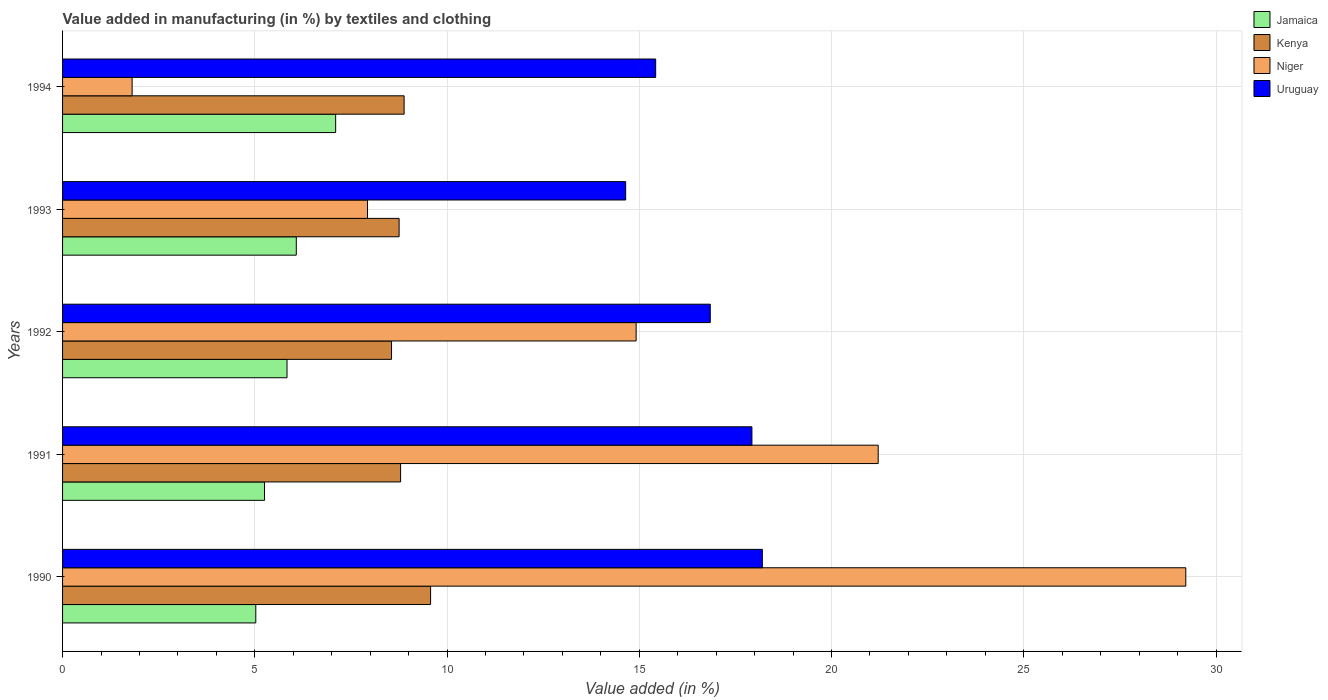How many groups of bars are there?
Give a very brief answer. 5. Are the number of bars on each tick of the Y-axis equal?
Your response must be concise. Yes. In how many cases, is the number of bars for a given year not equal to the number of legend labels?
Offer a terse response. 0. What is the percentage of value added in manufacturing by textiles and clothing in Kenya in 1990?
Provide a short and direct response. 9.57. Across all years, what is the maximum percentage of value added in manufacturing by textiles and clothing in Kenya?
Give a very brief answer. 9.57. Across all years, what is the minimum percentage of value added in manufacturing by textiles and clothing in Jamaica?
Ensure brevity in your answer.  5.03. What is the total percentage of value added in manufacturing by textiles and clothing in Jamaica in the graph?
Your answer should be compact. 29.3. What is the difference between the percentage of value added in manufacturing by textiles and clothing in Jamaica in 1990 and that in 1991?
Your answer should be very brief. -0.23. What is the difference between the percentage of value added in manufacturing by textiles and clothing in Uruguay in 1992 and the percentage of value added in manufacturing by textiles and clothing in Niger in 1991?
Offer a very short reply. -4.37. What is the average percentage of value added in manufacturing by textiles and clothing in Niger per year?
Offer a very short reply. 15.02. In the year 1994, what is the difference between the percentage of value added in manufacturing by textiles and clothing in Uruguay and percentage of value added in manufacturing by textiles and clothing in Jamaica?
Ensure brevity in your answer.  8.32. In how many years, is the percentage of value added in manufacturing by textiles and clothing in Jamaica greater than 1 %?
Provide a short and direct response. 5. What is the ratio of the percentage of value added in manufacturing by textiles and clothing in Niger in 1991 to that in 1994?
Keep it short and to the point. 11.73. Is the difference between the percentage of value added in manufacturing by textiles and clothing in Uruguay in 1990 and 1993 greater than the difference between the percentage of value added in manufacturing by textiles and clothing in Jamaica in 1990 and 1993?
Offer a terse response. Yes. What is the difference between the highest and the second highest percentage of value added in manufacturing by textiles and clothing in Jamaica?
Ensure brevity in your answer.  1.02. What is the difference between the highest and the lowest percentage of value added in manufacturing by textiles and clothing in Niger?
Provide a short and direct response. 27.4. In how many years, is the percentage of value added in manufacturing by textiles and clothing in Uruguay greater than the average percentage of value added in manufacturing by textiles and clothing in Uruguay taken over all years?
Give a very brief answer. 3. What does the 1st bar from the top in 1990 represents?
Offer a very short reply. Uruguay. What does the 3rd bar from the bottom in 1992 represents?
Keep it short and to the point. Niger. Is it the case that in every year, the sum of the percentage of value added in manufacturing by textiles and clothing in Uruguay and percentage of value added in manufacturing by textiles and clothing in Jamaica is greater than the percentage of value added in manufacturing by textiles and clothing in Niger?
Provide a succinct answer. No. How many bars are there?
Your answer should be compact. 20. How many years are there in the graph?
Your response must be concise. 5. What is the difference between two consecutive major ticks on the X-axis?
Offer a terse response. 5. Where does the legend appear in the graph?
Your answer should be compact. Top right. How are the legend labels stacked?
Keep it short and to the point. Vertical. What is the title of the graph?
Make the answer very short. Value added in manufacturing (in %) by textiles and clothing. What is the label or title of the X-axis?
Your answer should be very brief. Value added (in %). What is the Value added (in %) in Jamaica in 1990?
Provide a short and direct response. 5.03. What is the Value added (in %) of Kenya in 1990?
Provide a succinct answer. 9.57. What is the Value added (in %) in Niger in 1990?
Keep it short and to the point. 29.21. What is the Value added (in %) of Uruguay in 1990?
Your answer should be very brief. 18.2. What is the Value added (in %) in Jamaica in 1991?
Make the answer very short. 5.25. What is the Value added (in %) in Kenya in 1991?
Offer a very short reply. 8.79. What is the Value added (in %) of Niger in 1991?
Offer a very short reply. 21.21. What is the Value added (in %) of Uruguay in 1991?
Ensure brevity in your answer.  17.93. What is the Value added (in %) in Jamaica in 1992?
Ensure brevity in your answer.  5.84. What is the Value added (in %) of Kenya in 1992?
Offer a very short reply. 8.56. What is the Value added (in %) of Niger in 1992?
Your answer should be compact. 14.92. What is the Value added (in %) of Uruguay in 1992?
Keep it short and to the point. 16.85. What is the Value added (in %) in Jamaica in 1993?
Make the answer very short. 6.08. What is the Value added (in %) of Kenya in 1993?
Provide a short and direct response. 8.75. What is the Value added (in %) of Niger in 1993?
Your answer should be compact. 7.93. What is the Value added (in %) in Uruguay in 1993?
Your answer should be very brief. 14.65. What is the Value added (in %) of Jamaica in 1994?
Provide a short and direct response. 7.1. What is the Value added (in %) of Kenya in 1994?
Provide a short and direct response. 8.88. What is the Value added (in %) of Niger in 1994?
Keep it short and to the point. 1.81. What is the Value added (in %) in Uruguay in 1994?
Your answer should be compact. 15.43. Across all years, what is the maximum Value added (in %) of Jamaica?
Keep it short and to the point. 7.1. Across all years, what is the maximum Value added (in %) in Kenya?
Keep it short and to the point. 9.57. Across all years, what is the maximum Value added (in %) of Niger?
Keep it short and to the point. 29.21. Across all years, what is the maximum Value added (in %) in Uruguay?
Provide a short and direct response. 18.2. Across all years, what is the minimum Value added (in %) of Jamaica?
Your response must be concise. 5.03. Across all years, what is the minimum Value added (in %) in Kenya?
Give a very brief answer. 8.56. Across all years, what is the minimum Value added (in %) of Niger?
Provide a short and direct response. 1.81. Across all years, what is the minimum Value added (in %) in Uruguay?
Give a very brief answer. 14.65. What is the total Value added (in %) in Jamaica in the graph?
Provide a short and direct response. 29.3. What is the total Value added (in %) of Kenya in the graph?
Offer a terse response. 44.56. What is the total Value added (in %) in Niger in the graph?
Keep it short and to the point. 75.09. What is the total Value added (in %) in Uruguay in the graph?
Make the answer very short. 83.05. What is the difference between the Value added (in %) in Jamaica in 1990 and that in 1991?
Give a very brief answer. -0.23. What is the difference between the Value added (in %) of Kenya in 1990 and that in 1991?
Keep it short and to the point. 0.78. What is the difference between the Value added (in %) in Niger in 1990 and that in 1991?
Give a very brief answer. 8. What is the difference between the Value added (in %) of Uruguay in 1990 and that in 1991?
Keep it short and to the point. 0.27. What is the difference between the Value added (in %) of Jamaica in 1990 and that in 1992?
Keep it short and to the point. -0.81. What is the difference between the Value added (in %) of Kenya in 1990 and that in 1992?
Keep it short and to the point. 1.02. What is the difference between the Value added (in %) in Niger in 1990 and that in 1992?
Offer a terse response. 14.3. What is the difference between the Value added (in %) in Uruguay in 1990 and that in 1992?
Keep it short and to the point. 1.35. What is the difference between the Value added (in %) of Jamaica in 1990 and that in 1993?
Your response must be concise. -1.05. What is the difference between the Value added (in %) of Kenya in 1990 and that in 1993?
Offer a terse response. 0.82. What is the difference between the Value added (in %) of Niger in 1990 and that in 1993?
Provide a short and direct response. 21.28. What is the difference between the Value added (in %) in Uruguay in 1990 and that in 1993?
Give a very brief answer. 3.55. What is the difference between the Value added (in %) of Jamaica in 1990 and that in 1994?
Your response must be concise. -2.08. What is the difference between the Value added (in %) of Kenya in 1990 and that in 1994?
Make the answer very short. 0.69. What is the difference between the Value added (in %) of Niger in 1990 and that in 1994?
Provide a succinct answer. 27.4. What is the difference between the Value added (in %) in Uruguay in 1990 and that in 1994?
Offer a very short reply. 2.77. What is the difference between the Value added (in %) of Jamaica in 1991 and that in 1992?
Offer a very short reply. -0.59. What is the difference between the Value added (in %) of Kenya in 1991 and that in 1992?
Ensure brevity in your answer.  0.24. What is the difference between the Value added (in %) in Niger in 1991 and that in 1992?
Keep it short and to the point. 6.3. What is the difference between the Value added (in %) of Uruguay in 1991 and that in 1992?
Your answer should be very brief. 1.08. What is the difference between the Value added (in %) in Jamaica in 1991 and that in 1993?
Provide a succinct answer. -0.83. What is the difference between the Value added (in %) in Kenya in 1991 and that in 1993?
Your answer should be compact. 0.04. What is the difference between the Value added (in %) in Niger in 1991 and that in 1993?
Provide a succinct answer. 13.28. What is the difference between the Value added (in %) of Uruguay in 1991 and that in 1993?
Your answer should be very brief. 3.28. What is the difference between the Value added (in %) in Jamaica in 1991 and that in 1994?
Keep it short and to the point. -1.85. What is the difference between the Value added (in %) of Kenya in 1991 and that in 1994?
Offer a very short reply. -0.09. What is the difference between the Value added (in %) of Niger in 1991 and that in 1994?
Ensure brevity in your answer.  19.4. What is the difference between the Value added (in %) in Uruguay in 1991 and that in 1994?
Your response must be concise. 2.5. What is the difference between the Value added (in %) of Jamaica in 1992 and that in 1993?
Offer a very short reply. -0.24. What is the difference between the Value added (in %) in Kenya in 1992 and that in 1993?
Give a very brief answer. -0.2. What is the difference between the Value added (in %) of Niger in 1992 and that in 1993?
Keep it short and to the point. 6.99. What is the difference between the Value added (in %) in Uruguay in 1992 and that in 1993?
Your response must be concise. 2.2. What is the difference between the Value added (in %) in Jamaica in 1992 and that in 1994?
Provide a succinct answer. -1.26. What is the difference between the Value added (in %) in Kenya in 1992 and that in 1994?
Ensure brevity in your answer.  -0.33. What is the difference between the Value added (in %) of Niger in 1992 and that in 1994?
Keep it short and to the point. 13.11. What is the difference between the Value added (in %) in Uruguay in 1992 and that in 1994?
Provide a short and direct response. 1.42. What is the difference between the Value added (in %) of Jamaica in 1993 and that in 1994?
Offer a very short reply. -1.02. What is the difference between the Value added (in %) in Kenya in 1993 and that in 1994?
Provide a succinct answer. -0.13. What is the difference between the Value added (in %) in Niger in 1993 and that in 1994?
Provide a succinct answer. 6.12. What is the difference between the Value added (in %) in Uruguay in 1993 and that in 1994?
Offer a very short reply. -0.78. What is the difference between the Value added (in %) of Jamaica in 1990 and the Value added (in %) of Kenya in 1991?
Offer a terse response. -3.77. What is the difference between the Value added (in %) of Jamaica in 1990 and the Value added (in %) of Niger in 1991?
Your answer should be very brief. -16.19. What is the difference between the Value added (in %) in Jamaica in 1990 and the Value added (in %) in Uruguay in 1991?
Offer a very short reply. -12.9. What is the difference between the Value added (in %) of Kenya in 1990 and the Value added (in %) of Niger in 1991?
Offer a very short reply. -11.64. What is the difference between the Value added (in %) in Kenya in 1990 and the Value added (in %) in Uruguay in 1991?
Provide a short and direct response. -8.36. What is the difference between the Value added (in %) in Niger in 1990 and the Value added (in %) in Uruguay in 1991?
Your response must be concise. 11.28. What is the difference between the Value added (in %) of Jamaica in 1990 and the Value added (in %) of Kenya in 1992?
Give a very brief answer. -3.53. What is the difference between the Value added (in %) of Jamaica in 1990 and the Value added (in %) of Niger in 1992?
Give a very brief answer. -9.89. What is the difference between the Value added (in %) of Jamaica in 1990 and the Value added (in %) of Uruguay in 1992?
Your answer should be very brief. -11.82. What is the difference between the Value added (in %) in Kenya in 1990 and the Value added (in %) in Niger in 1992?
Your response must be concise. -5.35. What is the difference between the Value added (in %) of Kenya in 1990 and the Value added (in %) of Uruguay in 1992?
Your response must be concise. -7.27. What is the difference between the Value added (in %) of Niger in 1990 and the Value added (in %) of Uruguay in 1992?
Make the answer very short. 12.37. What is the difference between the Value added (in %) of Jamaica in 1990 and the Value added (in %) of Kenya in 1993?
Give a very brief answer. -3.73. What is the difference between the Value added (in %) in Jamaica in 1990 and the Value added (in %) in Niger in 1993?
Provide a succinct answer. -2.91. What is the difference between the Value added (in %) of Jamaica in 1990 and the Value added (in %) of Uruguay in 1993?
Make the answer very short. -9.62. What is the difference between the Value added (in %) in Kenya in 1990 and the Value added (in %) in Niger in 1993?
Provide a succinct answer. 1.64. What is the difference between the Value added (in %) in Kenya in 1990 and the Value added (in %) in Uruguay in 1993?
Provide a succinct answer. -5.07. What is the difference between the Value added (in %) in Niger in 1990 and the Value added (in %) in Uruguay in 1993?
Ensure brevity in your answer.  14.57. What is the difference between the Value added (in %) of Jamaica in 1990 and the Value added (in %) of Kenya in 1994?
Offer a terse response. -3.86. What is the difference between the Value added (in %) of Jamaica in 1990 and the Value added (in %) of Niger in 1994?
Give a very brief answer. 3.22. What is the difference between the Value added (in %) of Jamaica in 1990 and the Value added (in %) of Uruguay in 1994?
Ensure brevity in your answer.  -10.4. What is the difference between the Value added (in %) of Kenya in 1990 and the Value added (in %) of Niger in 1994?
Provide a succinct answer. 7.76. What is the difference between the Value added (in %) of Kenya in 1990 and the Value added (in %) of Uruguay in 1994?
Give a very brief answer. -5.85. What is the difference between the Value added (in %) of Niger in 1990 and the Value added (in %) of Uruguay in 1994?
Keep it short and to the point. 13.79. What is the difference between the Value added (in %) in Jamaica in 1991 and the Value added (in %) in Kenya in 1992?
Offer a very short reply. -3.3. What is the difference between the Value added (in %) in Jamaica in 1991 and the Value added (in %) in Niger in 1992?
Offer a very short reply. -9.67. What is the difference between the Value added (in %) in Jamaica in 1991 and the Value added (in %) in Uruguay in 1992?
Your answer should be very brief. -11.59. What is the difference between the Value added (in %) in Kenya in 1991 and the Value added (in %) in Niger in 1992?
Your answer should be compact. -6.13. What is the difference between the Value added (in %) of Kenya in 1991 and the Value added (in %) of Uruguay in 1992?
Ensure brevity in your answer.  -8.05. What is the difference between the Value added (in %) of Niger in 1991 and the Value added (in %) of Uruguay in 1992?
Give a very brief answer. 4.37. What is the difference between the Value added (in %) of Jamaica in 1991 and the Value added (in %) of Kenya in 1993?
Provide a succinct answer. -3.5. What is the difference between the Value added (in %) of Jamaica in 1991 and the Value added (in %) of Niger in 1993?
Your response must be concise. -2.68. What is the difference between the Value added (in %) in Jamaica in 1991 and the Value added (in %) in Uruguay in 1993?
Provide a short and direct response. -9.39. What is the difference between the Value added (in %) of Kenya in 1991 and the Value added (in %) of Niger in 1993?
Offer a very short reply. 0.86. What is the difference between the Value added (in %) of Kenya in 1991 and the Value added (in %) of Uruguay in 1993?
Keep it short and to the point. -5.85. What is the difference between the Value added (in %) in Niger in 1991 and the Value added (in %) in Uruguay in 1993?
Make the answer very short. 6.57. What is the difference between the Value added (in %) in Jamaica in 1991 and the Value added (in %) in Kenya in 1994?
Give a very brief answer. -3.63. What is the difference between the Value added (in %) in Jamaica in 1991 and the Value added (in %) in Niger in 1994?
Your response must be concise. 3.44. What is the difference between the Value added (in %) in Jamaica in 1991 and the Value added (in %) in Uruguay in 1994?
Make the answer very short. -10.17. What is the difference between the Value added (in %) in Kenya in 1991 and the Value added (in %) in Niger in 1994?
Your response must be concise. 6.98. What is the difference between the Value added (in %) in Kenya in 1991 and the Value added (in %) in Uruguay in 1994?
Your answer should be compact. -6.63. What is the difference between the Value added (in %) of Niger in 1991 and the Value added (in %) of Uruguay in 1994?
Offer a very short reply. 5.79. What is the difference between the Value added (in %) of Jamaica in 1992 and the Value added (in %) of Kenya in 1993?
Provide a succinct answer. -2.92. What is the difference between the Value added (in %) in Jamaica in 1992 and the Value added (in %) in Niger in 1993?
Your response must be concise. -2.09. What is the difference between the Value added (in %) of Jamaica in 1992 and the Value added (in %) of Uruguay in 1993?
Offer a very short reply. -8.81. What is the difference between the Value added (in %) of Kenya in 1992 and the Value added (in %) of Niger in 1993?
Provide a succinct answer. 0.62. What is the difference between the Value added (in %) of Kenya in 1992 and the Value added (in %) of Uruguay in 1993?
Ensure brevity in your answer.  -6.09. What is the difference between the Value added (in %) of Niger in 1992 and the Value added (in %) of Uruguay in 1993?
Your answer should be compact. 0.27. What is the difference between the Value added (in %) of Jamaica in 1992 and the Value added (in %) of Kenya in 1994?
Provide a short and direct response. -3.05. What is the difference between the Value added (in %) of Jamaica in 1992 and the Value added (in %) of Niger in 1994?
Offer a very short reply. 4.03. What is the difference between the Value added (in %) in Jamaica in 1992 and the Value added (in %) in Uruguay in 1994?
Your response must be concise. -9.59. What is the difference between the Value added (in %) of Kenya in 1992 and the Value added (in %) of Niger in 1994?
Offer a terse response. 6.75. What is the difference between the Value added (in %) of Kenya in 1992 and the Value added (in %) of Uruguay in 1994?
Your answer should be very brief. -6.87. What is the difference between the Value added (in %) in Niger in 1992 and the Value added (in %) in Uruguay in 1994?
Provide a short and direct response. -0.51. What is the difference between the Value added (in %) in Jamaica in 1993 and the Value added (in %) in Kenya in 1994?
Provide a succinct answer. -2.8. What is the difference between the Value added (in %) in Jamaica in 1993 and the Value added (in %) in Niger in 1994?
Give a very brief answer. 4.27. What is the difference between the Value added (in %) in Jamaica in 1993 and the Value added (in %) in Uruguay in 1994?
Ensure brevity in your answer.  -9.35. What is the difference between the Value added (in %) of Kenya in 1993 and the Value added (in %) of Niger in 1994?
Your response must be concise. 6.94. What is the difference between the Value added (in %) in Kenya in 1993 and the Value added (in %) in Uruguay in 1994?
Offer a terse response. -6.67. What is the difference between the Value added (in %) of Niger in 1993 and the Value added (in %) of Uruguay in 1994?
Provide a succinct answer. -7.49. What is the average Value added (in %) of Jamaica per year?
Your answer should be very brief. 5.86. What is the average Value added (in %) of Kenya per year?
Offer a terse response. 8.91. What is the average Value added (in %) of Niger per year?
Ensure brevity in your answer.  15.02. What is the average Value added (in %) of Uruguay per year?
Offer a very short reply. 16.61. In the year 1990, what is the difference between the Value added (in %) of Jamaica and Value added (in %) of Kenya?
Your answer should be compact. -4.55. In the year 1990, what is the difference between the Value added (in %) in Jamaica and Value added (in %) in Niger?
Keep it short and to the point. -24.19. In the year 1990, what is the difference between the Value added (in %) in Jamaica and Value added (in %) in Uruguay?
Provide a short and direct response. -13.17. In the year 1990, what is the difference between the Value added (in %) in Kenya and Value added (in %) in Niger?
Offer a terse response. -19.64. In the year 1990, what is the difference between the Value added (in %) in Kenya and Value added (in %) in Uruguay?
Make the answer very short. -8.63. In the year 1990, what is the difference between the Value added (in %) in Niger and Value added (in %) in Uruguay?
Make the answer very short. 11.01. In the year 1991, what is the difference between the Value added (in %) of Jamaica and Value added (in %) of Kenya?
Make the answer very short. -3.54. In the year 1991, what is the difference between the Value added (in %) in Jamaica and Value added (in %) in Niger?
Your answer should be compact. -15.96. In the year 1991, what is the difference between the Value added (in %) in Jamaica and Value added (in %) in Uruguay?
Keep it short and to the point. -12.68. In the year 1991, what is the difference between the Value added (in %) of Kenya and Value added (in %) of Niger?
Provide a succinct answer. -12.42. In the year 1991, what is the difference between the Value added (in %) in Kenya and Value added (in %) in Uruguay?
Your answer should be very brief. -9.14. In the year 1991, what is the difference between the Value added (in %) in Niger and Value added (in %) in Uruguay?
Offer a very short reply. 3.28. In the year 1992, what is the difference between the Value added (in %) in Jamaica and Value added (in %) in Kenya?
Provide a short and direct response. -2.72. In the year 1992, what is the difference between the Value added (in %) in Jamaica and Value added (in %) in Niger?
Give a very brief answer. -9.08. In the year 1992, what is the difference between the Value added (in %) in Jamaica and Value added (in %) in Uruguay?
Keep it short and to the point. -11.01. In the year 1992, what is the difference between the Value added (in %) of Kenya and Value added (in %) of Niger?
Keep it short and to the point. -6.36. In the year 1992, what is the difference between the Value added (in %) in Kenya and Value added (in %) in Uruguay?
Your answer should be compact. -8.29. In the year 1992, what is the difference between the Value added (in %) of Niger and Value added (in %) of Uruguay?
Your answer should be compact. -1.93. In the year 1993, what is the difference between the Value added (in %) of Jamaica and Value added (in %) of Kenya?
Keep it short and to the point. -2.67. In the year 1993, what is the difference between the Value added (in %) in Jamaica and Value added (in %) in Niger?
Ensure brevity in your answer.  -1.85. In the year 1993, what is the difference between the Value added (in %) in Jamaica and Value added (in %) in Uruguay?
Offer a terse response. -8.57. In the year 1993, what is the difference between the Value added (in %) of Kenya and Value added (in %) of Niger?
Your answer should be very brief. 0.82. In the year 1993, what is the difference between the Value added (in %) in Kenya and Value added (in %) in Uruguay?
Keep it short and to the point. -5.89. In the year 1993, what is the difference between the Value added (in %) in Niger and Value added (in %) in Uruguay?
Your answer should be compact. -6.71. In the year 1994, what is the difference between the Value added (in %) of Jamaica and Value added (in %) of Kenya?
Keep it short and to the point. -1.78. In the year 1994, what is the difference between the Value added (in %) in Jamaica and Value added (in %) in Niger?
Offer a terse response. 5.29. In the year 1994, what is the difference between the Value added (in %) in Jamaica and Value added (in %) in Uruguay?
Provide a succinct answer. -8.32. In the year 1994, what is the difference between the Value added (in %) in Kenya and Value added (in %) in Niger?
Your response must be concise. 7.07. In the year 1994, what is the difference between the Value added (in %) of Kenya and Value added (in %) of Uruguay?
Provide a short and direct response. -6.54. In the year 1994, what is the difference between the Value added (in %) of Niger and Value added (in %) of Uruguay?
Your response must be concise. -13.62. What is the ratio of the Value added (in %) of Jamaica in 1990 to that in 1991?
Your answer should be very brief. 0.96. What is the ratio of the Value added (in %) in Kenya in 1990 to that in 1991?
Make the answer very short. 1.09. What is the ratio of the Value added (in %) in Niger in 1990 to that in 1991?
Your answer should be compact. 1.38. What is the ratio of the Value added (in %) of Uruguay in 1990 to that in 1991?
Your answer should be compact. 1.02. What is the ratio of the Value added (in %) in Jamaica in 1990 to that in 1992?
Your answer should be very brief. 0.86. What is the ratio of the Value added (in %) of Kenya in 1990 to that in 1992?
Give a very brief answer. 1.12. What is the ratio of the Value added (in %) of Niger in 1990 to that in 1992?
Your answer should be compact. 1.96. What is the ratio of the Value added (in %) of Uruguay in 1990 to that in 1992?
Your response must be concise. 1.08. What is the ratio of the Value added (in %) in Jamaica in 1990 to that in 1993?
Ensure brevity in your answer.  0.83. What is the ratio of the Value added (in %) of Kenya in 1990 to that in 1993?
Offer a terse response. 1.09. What is the ratio of the Value added (in %) in Niger in 1990 to that in 1993?
Offer a very short reply. 3.68. What is the ratio of the Value added (in %) in Uruguay in 1990 to that in 1993?
Your answer should be very brief. 1.24. What is the ratio of the Value added (in %) of Jamaica in 1990 to that in 1994?
Make the answer very short. 0.71. What is the ratio of the Value added (in %) of Kenya in 1990 to that in 1994?
Make the answer very short. 1.08. What is the ratio of the Value added (in %) of Niger in 1990 to that in 1994?
Your answer should be compact. 16.15. What is the ratio of the Value added (in %) in Uruguay in 1990 to that in 1994?
Provide a succinct answer. 1.18. What is the ratio of the Value added (in %) in Jamaica in 1991 to that in 1992?
Keep it short and to the point. 0.9. What is the ratio of the Value added (in %) of Kenya in 1991 to that in 1992?
Offer a terse response. 1.03. What is the ratio of the Value added (in %) of Niger in 1991 to that in 1992?
Your answer should be compact. 1.42. What is the ratio of the Value added (in %) in Uruguay in 1991 to that in 1992?
Offer a terse response. 1.06. What is the ratio of the Value added (in %) of Jamaica in 1991 to that in 1993?
Offer a very short reply. 0.86. What is the ratio of the Value added (in %) of Kenya in 1991 to that in 1993?
Your answer should be compact. 1. What is the ratio of the Value added (in %) of Niger in 1991 to that in 1993?
Your answer should be very brief. 2.67. What is the ratio of the Value added (in %) in Uruguay in 1991 to that in 1993?
Keep it short and to the point. 1.22. What is the ratio of the Value added (in %) in Jamaica in 1991 to that in 1994?
Provide a succinct answer. 0.74. What is the ratio of the Value added (in %) in Kenya in 1991 to that in 1994?
Your response must be concise. 0.99. What is the ratio of the Value added (in %) in Niger in 1991 to that in 1994?
Your answer should be compact. 11.73. What is the ratio of the Value added (in %) in Uruguay in 1991 to that in 1994?
Your answer should be compact. 1.16. What is the ratio of the Value added (in %) of Jamaica in 1992 to that in 1993?
Your response must be concise. 0.96. What is the ratio of the Value added (in %) of Kenya in 1992 to that in 1993?
Give a very brief answer. 0.98. What is the ratio of the Value added (in %) of Niger in 1992 to that in 1993?
Your answer should be compact. 1.88. What is the ratio of the Value added (in %) of Uruguay in 1992 to that in 1993?
Give a very brief answer. 1.15. What is the ratio of the Value added (in %) in Jamaica in 1992 to that in 1994?
Your answer should be very brief. 0.82. What is the ratio of the Value added (in %) of Kenya in 1992 to that in 1994?
Your response must be concise. 0.96. What is the ratio of the Value added (in %) of Niger in 1992 to that in 1994?
Offer a very short reply. 8.25. What is the ratio of the Value added (in %) of Uruguay in 1992 to that in 1994?
Provide a succinct answer. 1.09. What is the ratio of the Value added (in %) of Jamaica in 1993 to that in 1994?
Ensure brevity in your answer.  0.86. What is the ratio of the Value added (in %) of Kenya in 1993 to that in 1994?
Provide a succinct answer. 0.99. What is the ratio of the Value added (in %) of Niger in 1993 to that in 1994?
Ensure brevity in your answer.  4.38. What is the ratio of the Value added (in %) in Uruguay in 1993 to that in 1994?
Offer a terse response. 0.95. What is the difference between the highest and the second highest Value added (in %) of Jamaica?
Offer a terse response. 1.02. What is the difference between the highest and the second highest Value added (in %) in Kenya?
Provide a short and direct response. 0.69. What is the difference between the highest and the second highest Value added (in %) of Niger?
Offer a terse response. 8. What is the difference between the highest and the second highest Value added (in %) of Uruguay?
Offer a terse response. 0.27. What is the difference between the highest and the lowest Value added (in %) in Jamaica?
Your answer should be very brief. 2.08. What is the difference between the highest and the lowest Value added (in %) in Kenya?
Offer a very short reply. 1.02. What is the difference between the highest and the lowest Value added (in %) in Niger?
Make the answer very short. 27.4. What is the difference between the highest and the lowest Value added (in %) in Uruguay?
Your response must be concise. 3.55. 